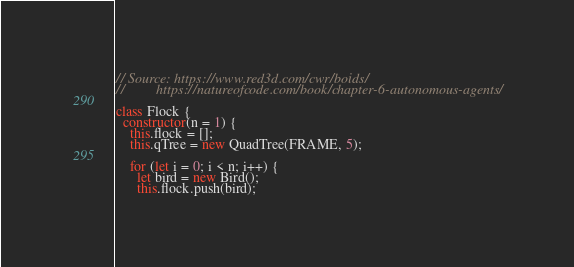Convert code to text. <code><loc_0><loc_0><loc_500><loc_500><_JavaScript_>// Source: https://www.red3d.com/cwr/boids/
//         https://natureofcode.com/book/chapter-6-autonomous-agents/

class Flock {
  constructor(n = 1) {
    this.flock = [];
    this.qTree = new QuadTree(FRAME, 5);

    for (let i = 0; i < n; i++) {
      let bird = new Bird();
      this.flock.push(bird);</code> 